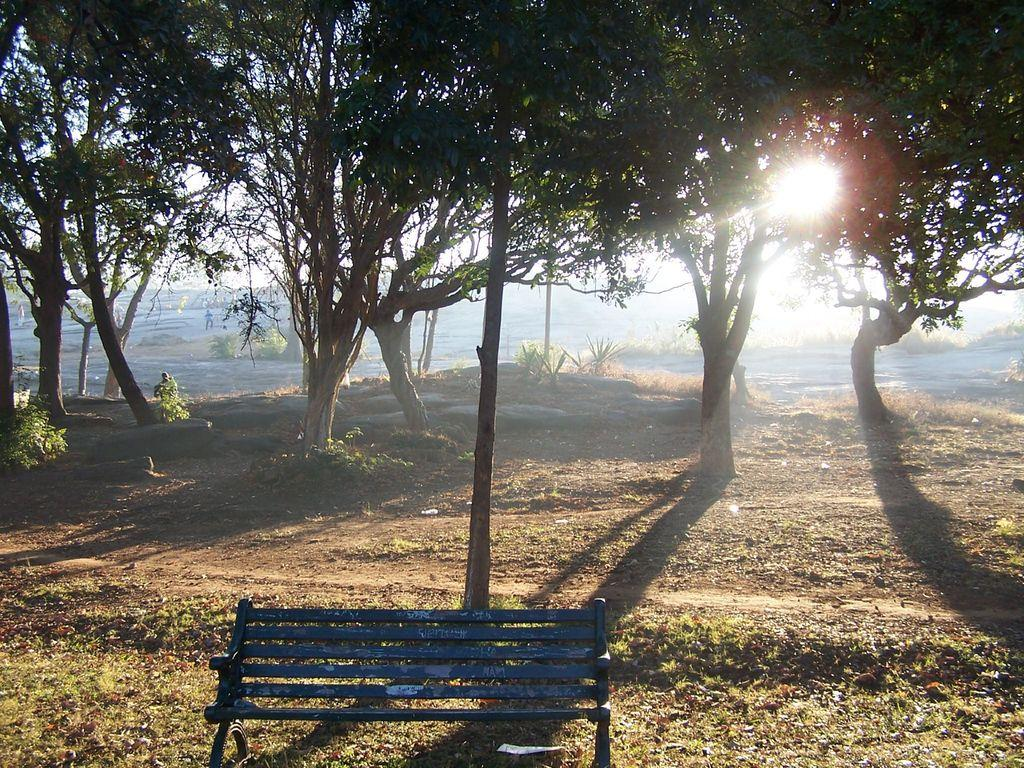What is the main feature of the landscape in the image? There are many trees in the image. Can you describe any man-made structures in the image? There is a bench near a pole in the image. What can be seen in the background of the image? There is water visible in the background of the image. What celestial body is observable in the image? The sun is observable in the image. What else is visible in the sky in the image? The sky is visible in the image. What type of clam is being cooked in the pot in the image? There is no pot or clam present in the image; it features trees, a bench, and a pole. What store can be seen in the background of the image? There is no store visible in the image; it features trees, a bench, and a pole with water in the background. 